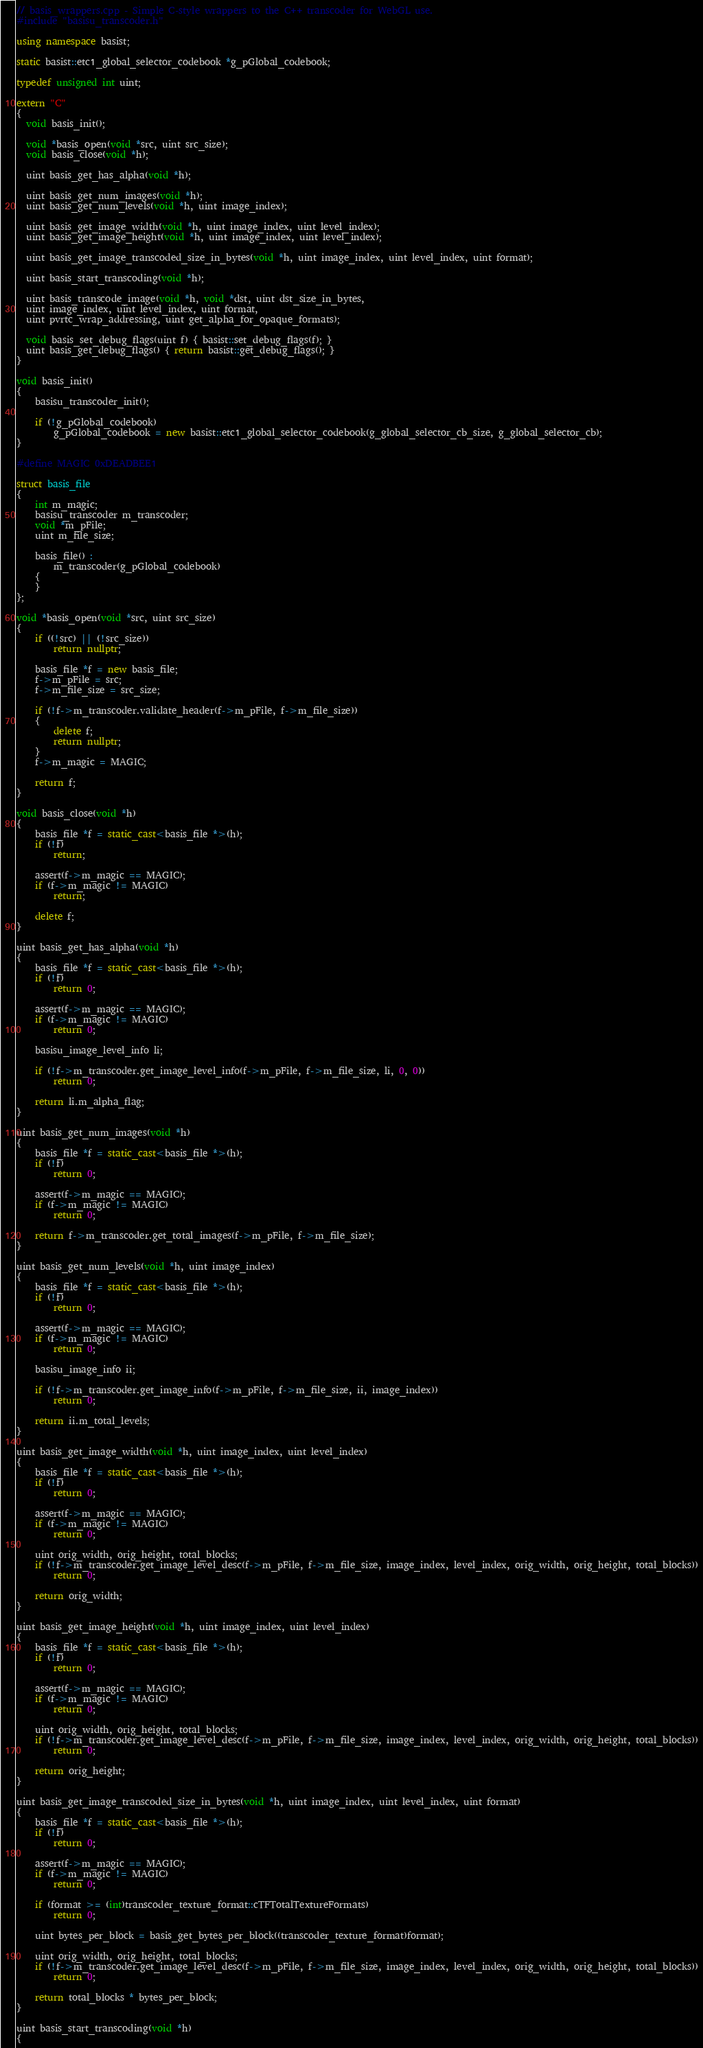Convert code to text. <code><loc_0><loc_0><loc_500><loc_500><_C++_>// basis_wrappers.cpp - Simple C-style wrappers to the C++ transcoder for WebGL use. 
#include "basisu_transcoder.h"

using namespace basist;

static basist::etc1_global_selector_codebook *g_pGlobal_codebook;

typedef unsigned int uint;

extern "C" 
{
  void basis_init();
  
  void *basis_open(void *src, uint src_size);
  void basis_close(void *h);

  uint basis_get_has_alpha(void *h);
	
  uint basis_get_num_images(void *h);
  uint basis_get_num_levels(void *h, uint image_index);
  
  uint basis_get_image_width(void *h, uint image_index, uint level_index);
  uint basis_get_image_height(void *h, uint image_index, uint level_index);
         
  uint basis_get_image_transcoded_size_in_bytes(void *h, uint image_index, uint level_index, uint format);
  
  uint basis_start_transcoding(void *h);
  
  uint basis_transcode_image(void *h, void *dst, uint dst_size_in_bytes, 
  uint image_index, uint level_index, uint format, 
  uint pvrtc_wrap_addressing, uint get_alpha_for_opaque_formats);
  
  void basis_set_debug_flags(uint f) { basist::set_debug_flags(f); }
  uint basis_get_debug_flags() { return basist::get_debug_flags(); }
}

void basis_init()
{
	basisu_transcoder_init();
	
	if (!g_pGlobal_codebook)
		g_pGlobal_codebook = new basist::etc1_global_selector_codebook(g_global_selector_cb_size, g_global_selector_cb);
}

#define MAGIC 0xDEADBEE1

struct basis_file
{
	int m_magic;
	basisu_transcoder m_transcoder;
	void *m_pFile;
	uint m_file_size;

	basis_file() : 
		m_transcoder(g_pGlobal_codebook)
	{
	}
};

void *basis_open(void *src, uint src_size)
{
	if ((!src) || (!src_size))
		return nullptr;
		
	basis_file *f = new basis_file;
	f->m_pFile = src;
	f->m_file_size = src_size;
	
	if (!f->m_transcoder.validate_header(f->m_pFile, f->m_file_size))
	{
		delete f;
		return nullptr;
	}
	f->m_magic = MAGIC;
	
	return f;
}

void basis_close(void *h)
{
	basis_file *f = static_cast<basis_file *>(h);
	if (!f)
		return;
	
	assert(f->m_magic == MAGIC);
	if (f->m_magic != MAGIC)
		return;
	
	delete f;
}

uint basis_get_has_alpha(void *h)
{
	basis_file *f = static_cast<basis_file *>(h);
	if (!f)
		return 0;

	assert(f->m_magic == MAGIC);	
	if (f->m_magic != MAGIC)
		return 0;
	
	basisu_image_level_info li;
	
	if (!f->m_transcoder.get_image_level_info(f->m_pFile, f->m_file_size, li, 0, 0))
		return 0;
		
	return li.m_alpha_flag;
}

uint basis_get_num_images(void *h)
{
	basis_file *f = static_cast<basis_file *>(h);
	if (!f)
		return 0;
	
	assert(f->m_magic == MAGIC);
	if (f->m_magic != MAGIC)
		return 0;
	
	return f->m_transcoder.get_total_images(f->m_pFile, f->m_file_size);
}

uint basis_get_num_levels(void *h, uint image_index)
{
	basis_file *f = static_cast<basis_file *>(h);
	if (!f)
		return 0;
	
	assert(f->m_magic == MAGIC);
	if (f->m_magic != MAGIC)
		return 0;
	
	basisu_image_info ii;
	
	if (!f->m_transcoder.get_image_info(f->m_pFile, f->m_file_size, ii, image_index))
		return 0;
		
	return ii.m_total_levels;
}

uint basis_get_image_width(void *h, uint image_index, uint level_index)
{
	basis_file *f = static_cast<basis_file *>(h);
	if (!f)
		return 0;
	
	assert(f->m_magic == MAGIC);
	if (f->m_magic != MAGIC)
		return 0;

	uint orig_width, orig_height, total_blocks;	
	if (!f->m_transcoder.get_image_level_desc(f->m_pFile, f->m_file_size, image_index, level_index, orig_width, orig_height, total_blocks))
		return 0;
	
	return orig_width;
}

uint basis_get_image_height(void *h, uint image_index, uint level_index)
{
	basis_file *f = static_cast<basis_file *>(h);
	if (!f)
		return 0;
	
	assert(f->m_magic == MAGIC);
	if (f->m_magic != MAGIC)
		return 0;		
	
	uint orig_width, orig_height, total_blocks;	
	if (!f->m_transcoder.get_image_level_desc(f->m_pFile, f->m_file_size, image_index, level_index, orig_width, orig_height, total_blocks))
		return 0;
	
	return orig_height;
}

uint basis_get_image_transcoded_size_in_bytes(void *h, uint image_index, uint level_index, uint format)
{
	basis_file *f = static_cast<basis_file *>(h);
	if (!f)
		return 0;
	
	assert(f->m_magic == MAGIC);	
	if (f->m_magic != MAGIC)
		return 0;	
	
	if (format >= (int)transcoder_texture_format::cTFTotalTextureFormats)
		return 0;
	
	uint bytes_per_block = basis_get_bytes_per_block((transcoder_texture_format)format);
	
	uint orig_width, orig_height, total_blocks;	
	if (!f->m_transcoder.get_image_level_desc(f->m_pFile, f->m_file_size, image_index, level_index, orig_width, orig_height, total_blocks))
		return 0;
	
	return total_blocks * bytes_per_block;
}

uint basis_start_transcoding(void *h)
{</code> 